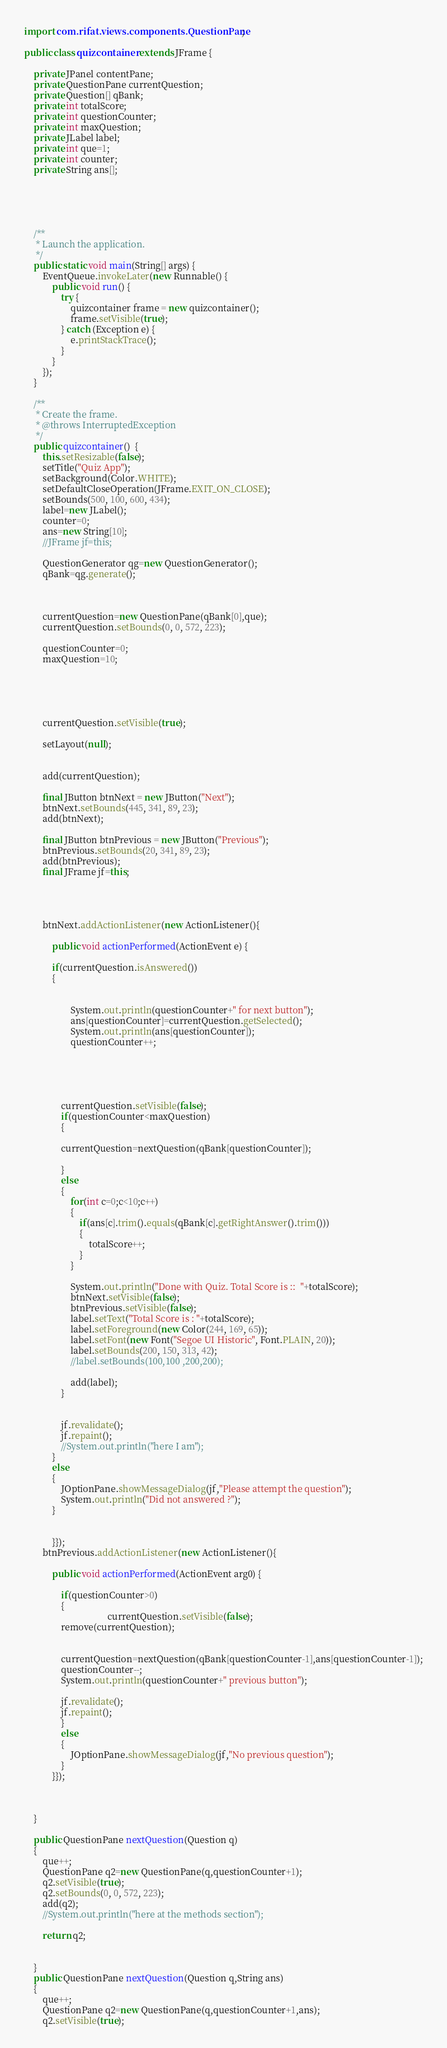<code> <loc_0><loc_0><loc_500><loc_500><_Java_>import com.rifat.views.components.QuestionPane;

public class quizcontainer extends JFrame {

	private JPanel contentPane;
	private QuestionPane currentQuestion;
	private Question[] qBank;
	private int totalScore;
	private int questionCounter;
	private int maxQuestion;
	private JLabel label;
	private int que=1;
	private int counter;
	private String ans[];
	

	
	

	/**
	 * Launch the application.
	 */
	public static void main(String[] args) {
		EventQueue.invokeLater(new Runnable() {
			public void run() {
				try {
					quizcontainer frame = new quizcontainer();
					frame.setVisible(true);
				} catch (Exception e) {
					e.printStackTrace();
				}
			}
		});
	}

	/**
	 * Create the frame.
	 * @throws InterruptedException 
	 */
	public quizcontainer()  {
		this.setResizable(false);
		setTitle("Quiz App");
		setBackground(Color.WHITE);
		setDefaultCloseOperation(JFrame.EXIT_ON_CLOSE);
		setBounds(500, 100, 600, 434);
		label=new JLabel();
		counter=0;
		ans=new String[10];
	    //JFrame jf=this;
		
		QuestionGenerator qg=new QuestionGenerator();
		qBank=qg.generate();
		
		
		
		currentQuestion=new QuestionPane(qBank[0],que);
		currentQuestion.setBounds(0, 0, 572, 223);
		
		questionCounter=0;		
		maxQuestion=10;
		
		 
	
	

		currentQuestion.setVisible(true);
		
		setLayout(null);
		
		
		add(currentQuestion);
		
		final JButton btnNext = new JButton("Next");
		btnNext.setBounds(445, 341, 89, 23);
		add(btnNext);
		
		final JButton btnPrevious = new JButton("Previous");
		btnPrevious.setBounds(20, 341, 89, 23);
		add(btnPrevious);
		final JFrame jf=this;
		
		
		
		
		btnNext.addActionListener(new ActionListener(){

			public void actionPerformed(ActionEvent e) {
				
			if(currentQuestion.isAnswered())
			{
				   
				
					System.out.println(questionCounter+" for next button");
					ans[questionCounter]=currentQuestion.getSelected();
					System.out.println(ans[questionCounter]);
					questionCounter++;
				
				
				
				
			
				currentQuestion.setVisible(false);
				if(questionCounter<maxQuestion)
				{
					
				currentQuestion=nextQuestion(qBank[questionCounter]);
				
				}
				else
				{
					for(int c=0;c<10;c++)
					{
						if(ans[c].trim().equals(qBank[c].getRightAnswer().trim()))
						{
							totalScore++;
						}
					}
					
					System.out.println("Done with Quiz. Total Score is ::  "+totalScore);
					btnNext.setVisible(false);
					btnPrevious.setVisible(false);
					label.setText("Total Score is : "+totalScore);
					label.setForeground(new Color(244, 169, 65));
					label.setFont(new Font("Segoe UI Historic", Font.PLAIN, 20));
					label.setBounds(200, 150, 313, 42);
					//label.setBounds(100,100 ,200,200);
					
					add(label);
				}
				
				
				jf.revalidate();
				jf.repaint();
				//System.out.println("here I am");
			}
			else
			{
				JOptionPane.showMessageDialog(jf,"Please attempt the question");
				System.out.println("Did not answered ?");
			}
				
				
			}});
		btnPrevious.addActionListener(new ActionListener(){

			public void actionPerformed(ActionEvent arg0) {
				
				if(questionCounter>0)
				{
									currentQuestion.setVisible(false);
				remove(currentQuestion);
				
				
				currentQuestion=nextQuestion(qBank[questionCounter-1],ans[questionCounter-1]);
				questionCounter--;
				System.out.println(questionCounter+" previous button");

				jf.revalidate();
				jf.repaint();
				}
				else
				{
					JOptionPane.showMessageDialog(jf,"No previous question");
				}
			}});
		
		
			
	}
	
	public QuestionPane nextQuestion(Question q)
	{
		que++;
		QuestionPane q2=new QuestionPane(q,questionCounter+1);
		q2.setVisible(true);
		q2.setBounds(0, 0, 572, 223);
		add(q2);
		//System.out.println("here at the methods section");
		
		return q2;
		
		
	}
	public QuestionPane nextQuestion(Question q,String ans)
	{
		que++;
		QuestionPane q2=new QuestionPane(q,questionCounter+1,ans);
		q2.setVisible(true);</code> 